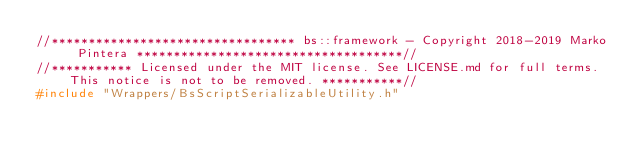<code> <loc_0><loc_0><loc_500><loc_500><_C++_>//********************************* bs::framework - Copyright 2018-2019 Marko Pintera ************************************//
//*********** Licensed under the MIT license. See LICENSE.md for full terms. This notice is not to be removed. ***********//
#include "Wrappers/BsScriptSerializableUtility.h"</code> 